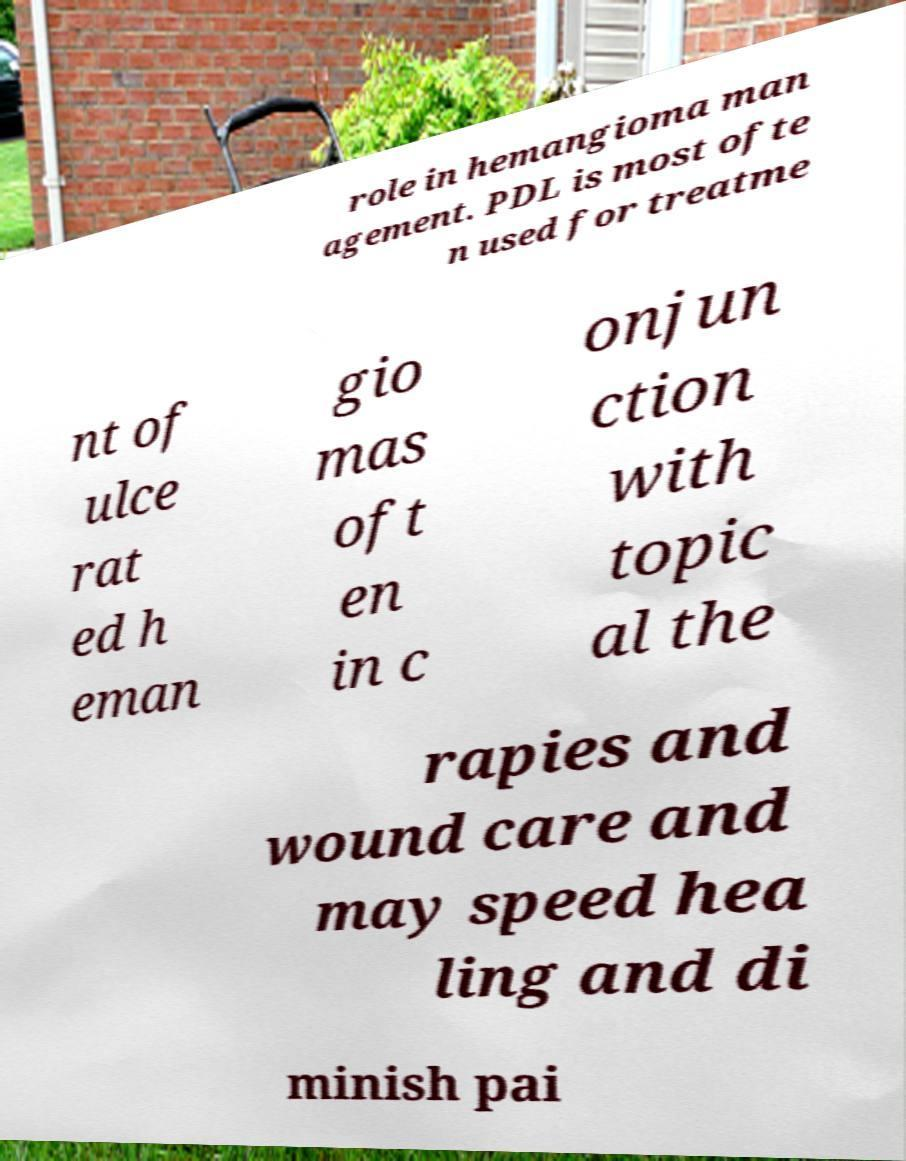For documentation purposes, I need the text within this image transcribed. Could you provide that? role in hemangioma man agement. PDL is most ofte n used for treatme nt of ulce rat ed h eman gio mas oft en in c onjun ction with topic al the rapies and wound care and may speed hea ling and di minish pai 